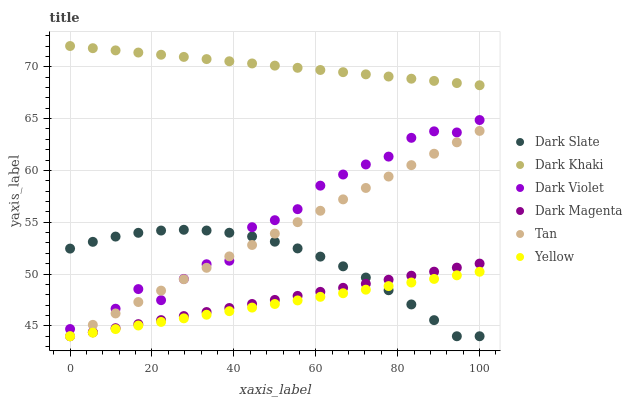Does Yellow have the minimum area under the curve?
Answer yes or no. Yes. Does Dark Khaki have the maximum area under the curve?
Answer yes or no. Yes. Does Dark Khaki have the minimum area under the curve?
Answer yes or no. No. Does Yellow have the maximum area under the curve?
Answer yes or no. No. Is Tan the smoothest?
Answer yes or no. Yes. Is Dark Violet the roughest?
Answer yes or no. Yes. Is Yellow the smoothest?
Answer yes or no. No. Is Yellow the roughest?
Answer yes or no. No. Does Dark Magenta have the lowest value?
Answer yes or no. Yes. Does Dark Khaki have the lowest value?
Answer yes or no. No. Does Dark Khaki have the highest value?
Answer yes or no. Yes. Does Yellow have the highest value?
Answer yes or no. No. Is Dark Magenta less than Dark Khaki?
Answer yes or no. Yes. Is Dark Violet greater than Yellow?
Answer yes or no. Yes. Does Yellow intersect Dark Magenta?
Answer yes or no. Yes. Is Yellow less than Dark Magenta?
Answer yes or no. No. Is Yellow greater than Dark Magenta?
Answer yes or no. No. Does Dark Magenta intersect Dark Khaki?
Answer yes or no. No. 